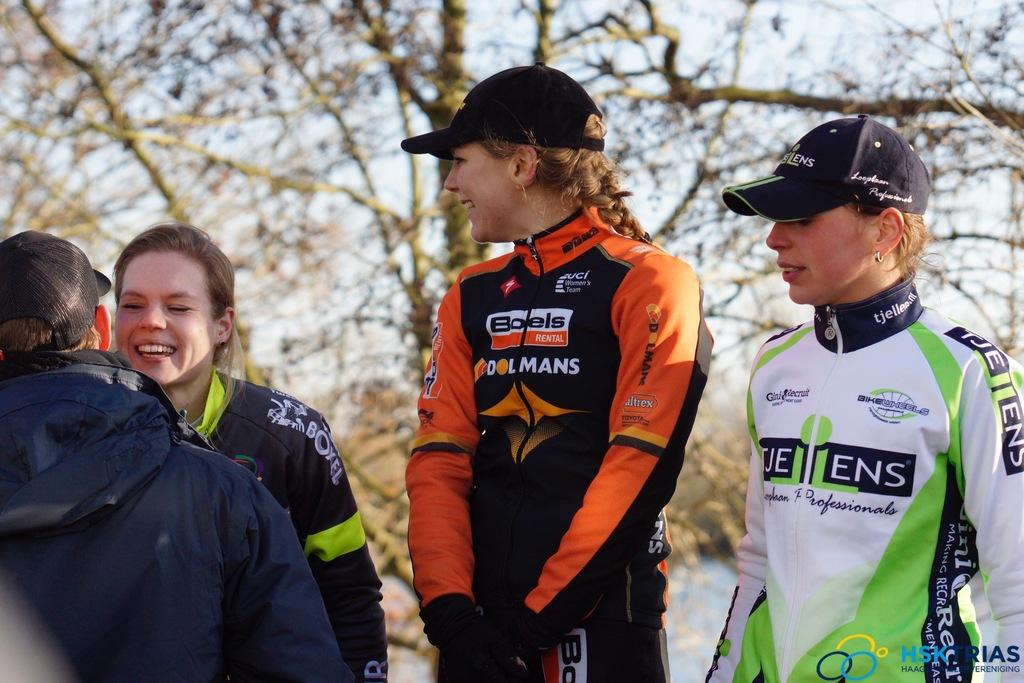<image>
Give a short and clear explanation of the subsequent image. A girl with a race suit sponsored by Boels stands among other women in racing suits. 